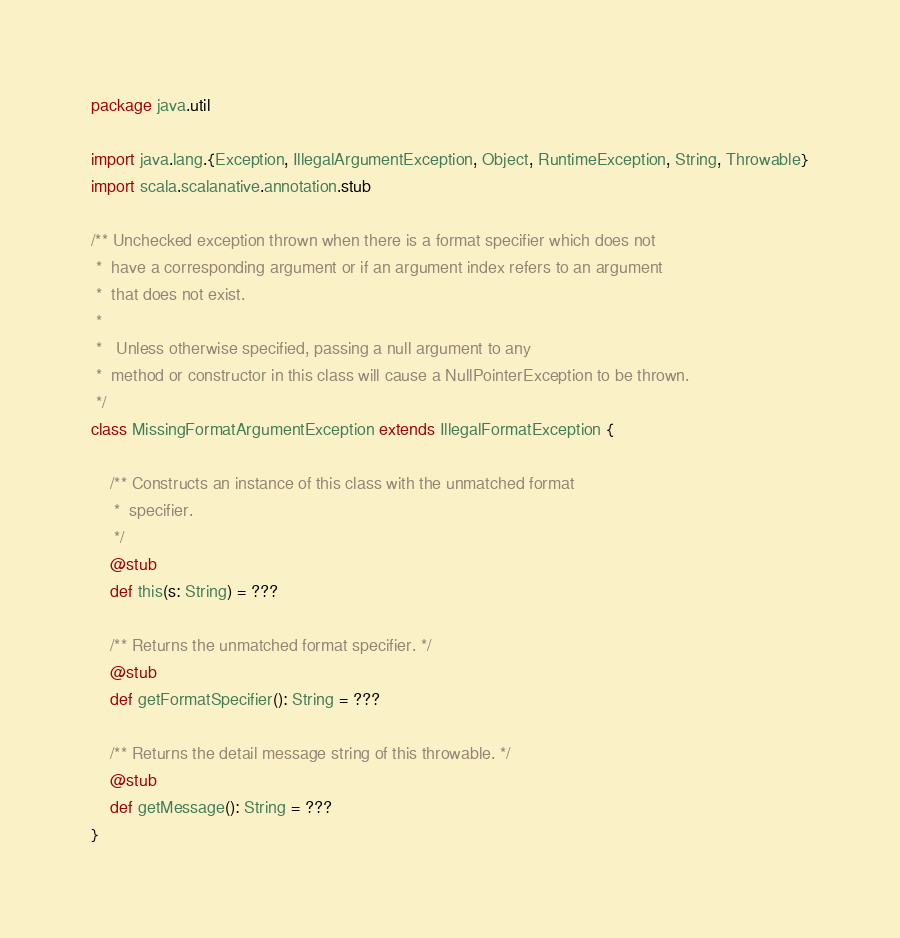<code> <loc_0><loc_0><loc_500><loc_500><_Scala_>package java.util

import java.lang.{Exception, IllegalArgumentException, Object, RuntimeException, String, Throwable}
import scala.scalanative.annotation.stub

/** Unchecked exception thrown when there is a format specifier which does not
 *  have a corresponding argument or if an argument index refers to an argument
 *  that does not exist.
 * 
 *   Unless otherwise specified, passing a null argument to any
 *  method or constructor in this class will cause a NullPointerException to be thrown.
 */
class MissingFormatArgumentException extends IllegalFormatException {

    /** Constructs an instance of this class with the unmatched format
     *  specifier.
     */
    @stub
    def this(s: String) = ???

    /** Returns the unmatched format specifier. */
    @stub
    def getFormatSpecifier(): String = ???

    /** Returns the detail message string of this throwable. */
    @stub
    def getMessage(): String = ???
}
</code> 